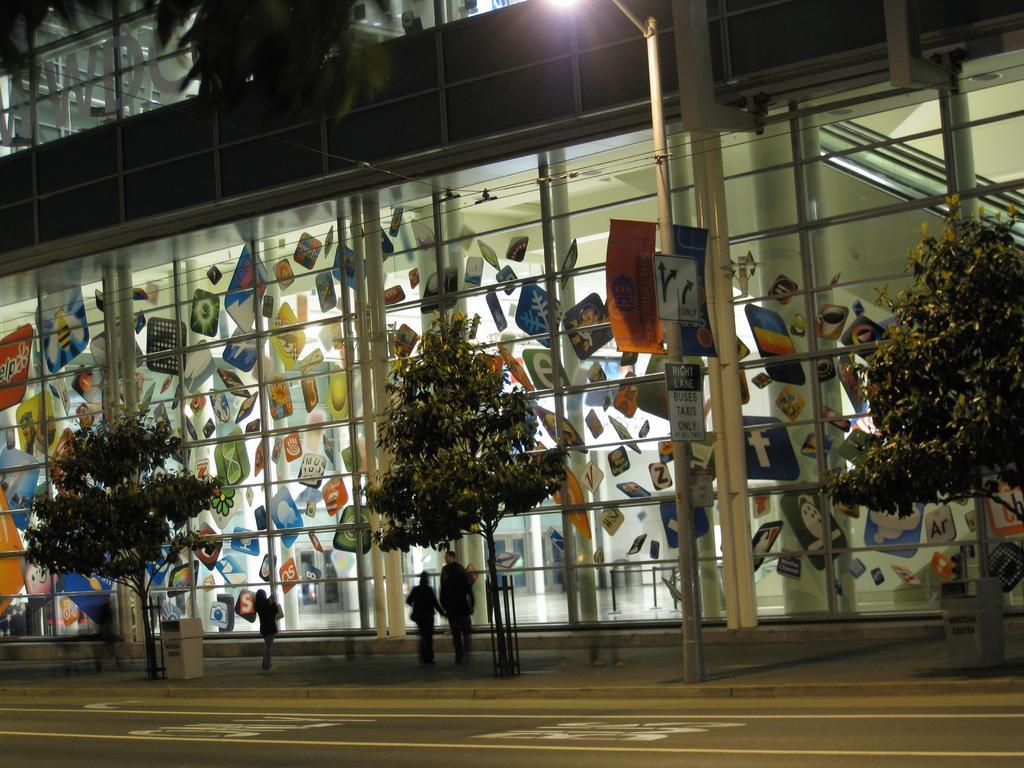Could you give a brief overview of what you see in this image? In this image I can see three persons standing on the sidewalk, a object which is white in color and few trees on the sidewalk. I can see the road, a metal pole, few boards attached to it and the light. In the background I can see the building. 